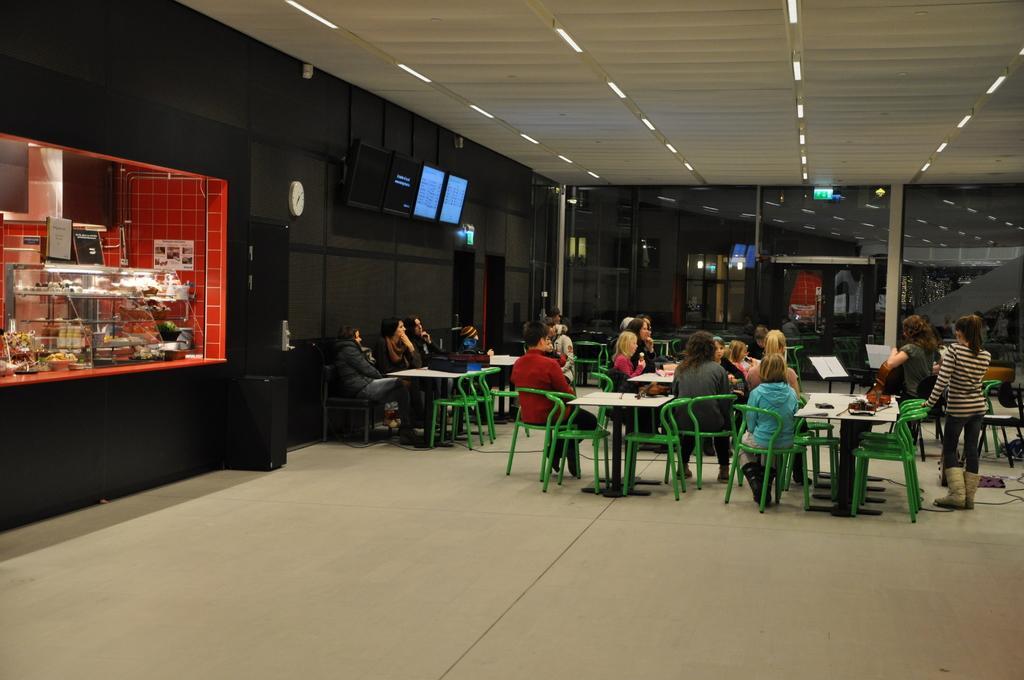Can you describe this image briefly? In this picture we can see a group of people on the ground, some people are sitting on chairs, some people are standing, here we can see tables, wall, televisions, clock, pillars, speakers, roof, lights and some objects, on the left side we can see a platform, here we can see food items, bowls, poster, name boards and some objects. 